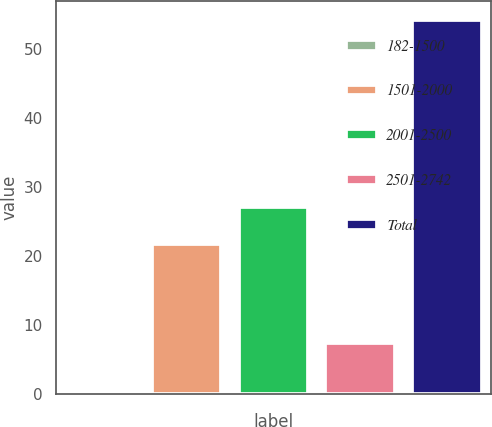<chart> <loc_0><loc_0><loc_500><loc_500><bar_chart><fcel>182-1500<fcel>1501-2000<fcel>2001-2500<fcel>2501-2742<fcel>Total<nl><fcel>0.4<fcel>21.7<fcel>27.08<fcel>7.4<fcel>54.2<nl></chart> 